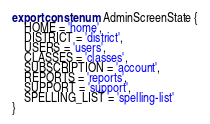<code> <loc_0><loc_0><loc_500><loc_500><_TypeScript_>export const enum AdminScreenState {
    HOME = 'home',
    DISTRICT = 'district',
    USERS = 'users',
    CLASSES = 'classes',    
    SUBSCRIPTION = 'account',    
    REPORTS = 'reports',
    SUPPORT = 'support',
    SPELLING_LIST = 'spelling-list'
}</code> 